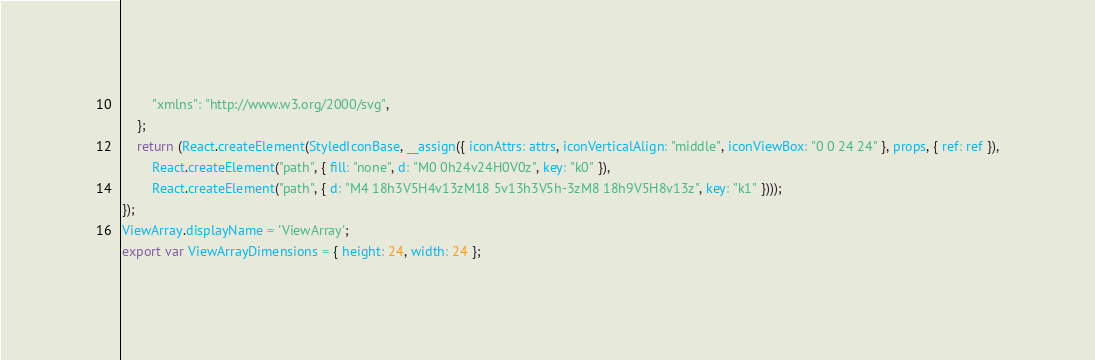Convert code to text. <code><loc_0><loc_0><loc_500><loc_500><_JavaScript_>        "xmlns": "http://www.w3.org/2000/svg",
    };
    return (React.createElement(StyledIconBase, __assign({ iconAttrs: attrs, iconVerticalAlign: "middle", iconViewBox: "0 0 24 24" }, props, { ref: ref }),
        React.createElement("path", { fill: "none", d: "M0 0h24v24H0V0z", key: "k0" }),
        React.createElement("path", { d: "M4 18h3V5H4v13zM18 5v13h3V5h-3zM8 18h9V5H8v13z", key: "k1" })));
});
ViewArray.displayName = 'ViewArray';
export var ViewArrayDimensions = { height: 24, width: 24 };
</code> 